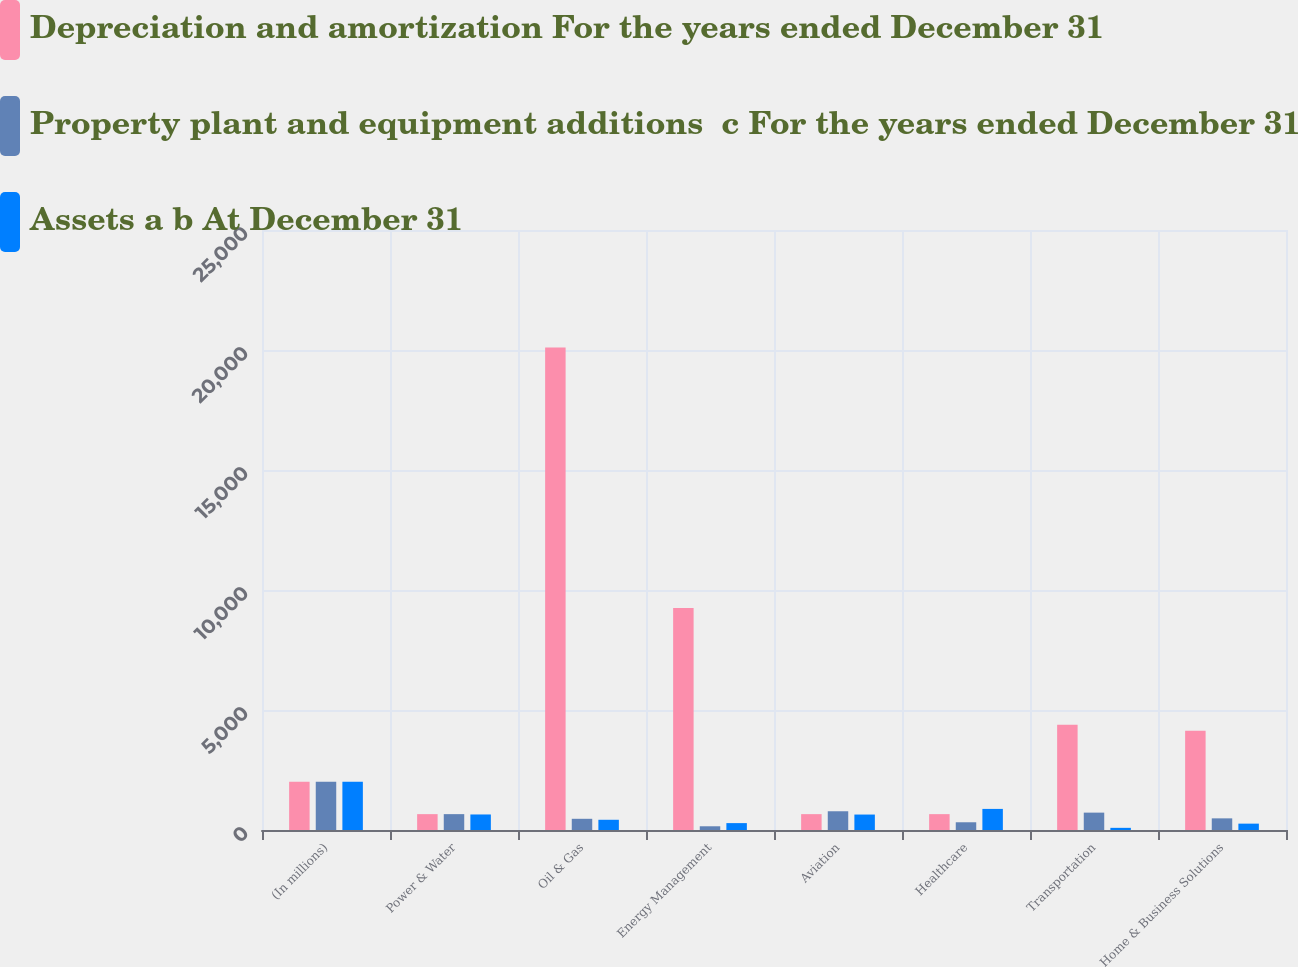Convert chart. <chart><loc_0><loc_0><loc_500><loc_500><stacked_bar_chart><ecel><fcel>(In millions)<fcel>Power & Water<fcel>Oil & Gas<fcel>Energy Management<fcel>Aviation<fcel>Healthcare<fcel>Transportation<fcel>Home & Business Solutions<nl><fcel>Depreciation and amortization For the years ended December 31<fcel>2012<fcel>661<fcel>20099<fcel>9253<fcel>661<fcel>661<fcel>4389<fcel>4133<nl><fcel>Property plant and equipment additions  c For the years ended December 31<fcel>2012<fcel>661<fcel>467<fcel>155<fcel>781<fcel>322<fcel>724<fcel>485<nl><fcel>Assets a b At December 31<fcel>2012<fcel>647<fcel>426<fcel>287<fcel>644<fcel>879<fcel>90<fcel>265<nl></chart> 